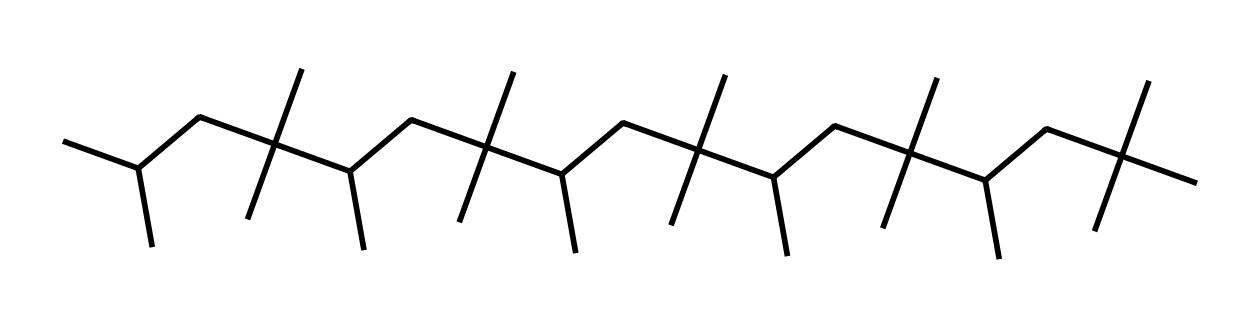What is the primary type of structure represented in this chemical? The chemical shown is a polyalphaolefin (PAO), characterized by a long carbon-chain structure with specific branching characteristics typical for synthetic base oils used in high-performance lubricants.
Answer: polyalphaolefin How many carbon atoms are in the chemical structure? By analyzing the SMILES representation, each "C" represents a carbon atom and counting them gives a total of 36 carbon atoms.
Answer: 36 What type of bonding is primarily present in this chemical structure? The structure is composed mainly of single carbon-carbon bonds and carbon-hydrogen bonds, which are standard in saturated hydrocarbons like PAOs.
Answer: single bonds What is the reason PAOs are preferred in high-performance lubricants? PAOs provide enhanced thermal stability, lower volatility, and better lubricating properties due to their uniform molecular structure compared to conventional mineral oils.
Answer: thermal stability Which part of the structure increases viscosity at high temperatures? The long carbon chains with branching in the PAO's structure contribute to its ability to maintain viscosity under increased temperatures, providing better lubrication in demanding conditions.
Answer: long carbon chains How does branching in the structure affect the properties of the lubricant? Branching reduces the intermolecular forces, which lowers the pour point and improves the low-temperature performance while maintaining lubricant effectiveness at high temperatures.
Answer: reduces intermolecular forces 